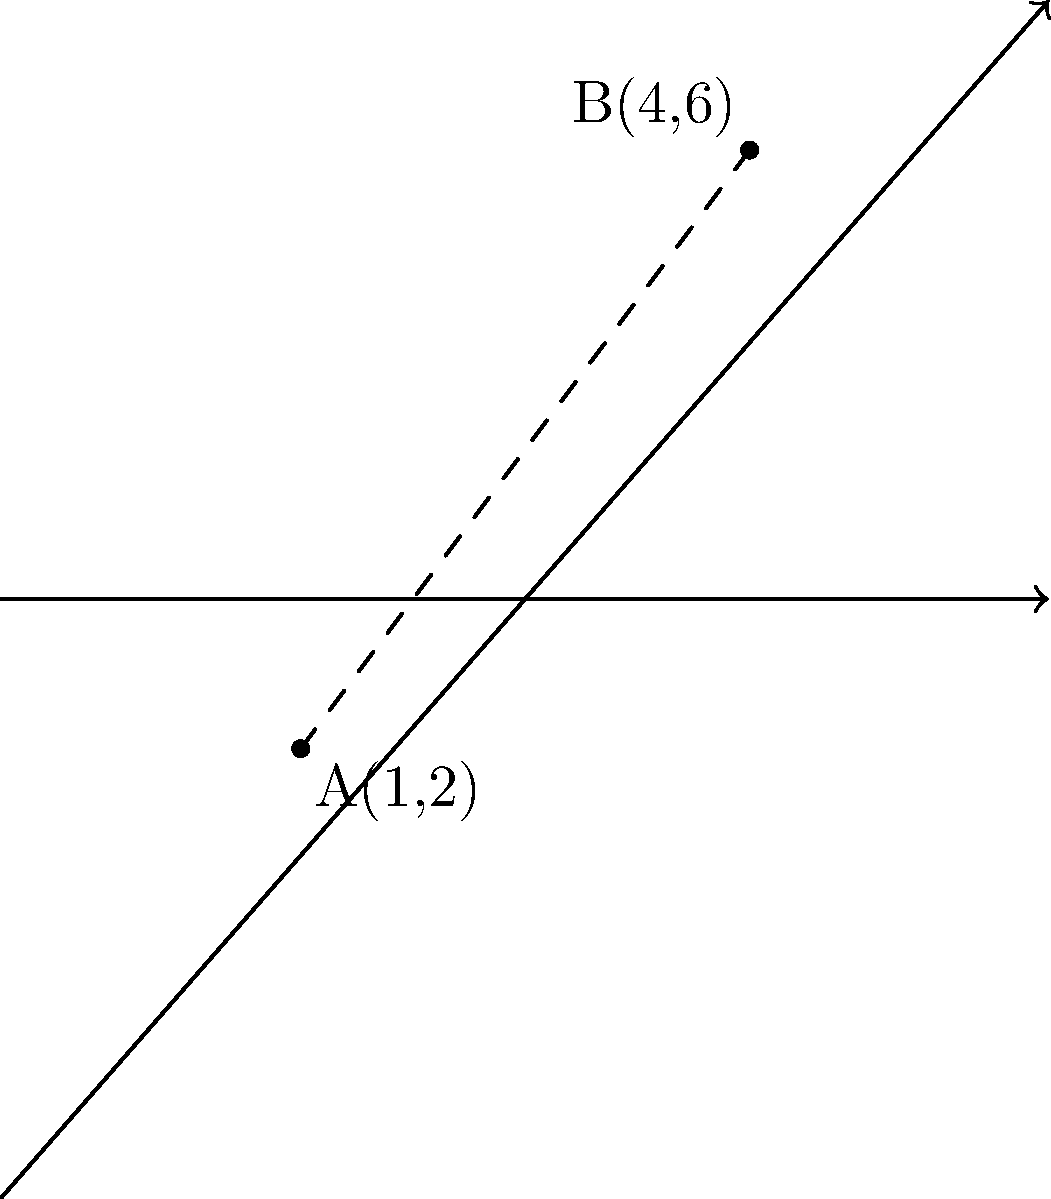In a photoshoot setup, two cameras are positioned at points A(1,2) and B(4,6) on a coordinate plane. As a photography lawyer advising on equipment placement, you need to calculate the distance between these two camera positions. What is the distance between points A and B? To calculate the distance between two points on a coordinate plane, we can use the distance formula, which is derived from the Pythagorean theorem:

$$d = \sqrt{(x_2 - x_1)^2 + (y_2 - y_1)^2}$$

Where $(x_1, y_1)$ are the coordinates of the first point and $(x_2, y_2)$ are the coordinates of the second point.

Given:
Point A: $(x_1, y_1) = (1, 2)$
Point B: $(x_2, y_2) = (4, 6)$

Let's substitute these values into the formula:

$$d = \sqrt{(4 - 1)^2 + (6 - 2)^2}$$

Now, let's solve step by step:

1. Calculate the differences:
   $$d = \sqrt{(3)^2 + (4)^2}$$

2. Square the differences:
   $$d = \sqrt{9 + 16}$$

3. Add the squared differences:
   $$d = \sqrt{25}$$

4. Take the square root:
   $$d = 5$$

Therefore, the distance between the two camera positions (points A and B) is 5 units.
Answer: 5 units 